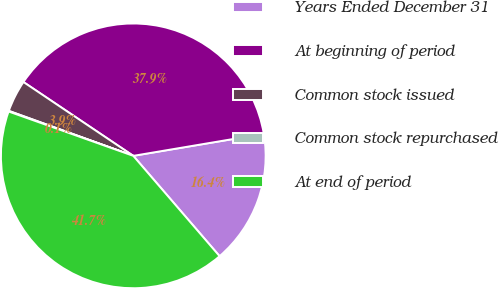Convert chart to OTSL. <chart><loc_0><loc_0><loc_500><loc_500><pie_chart><fcel>Years Ended December 31<fcel>At beginning of period<fcel>Common stock issued<fcel>Common stock repurchased<fcel>At end of period<nl><fcel>16.35%<fcel>37.92%<fcel>3.9%<fcel>0.08%<fcel>41.74%<nl></chart> 